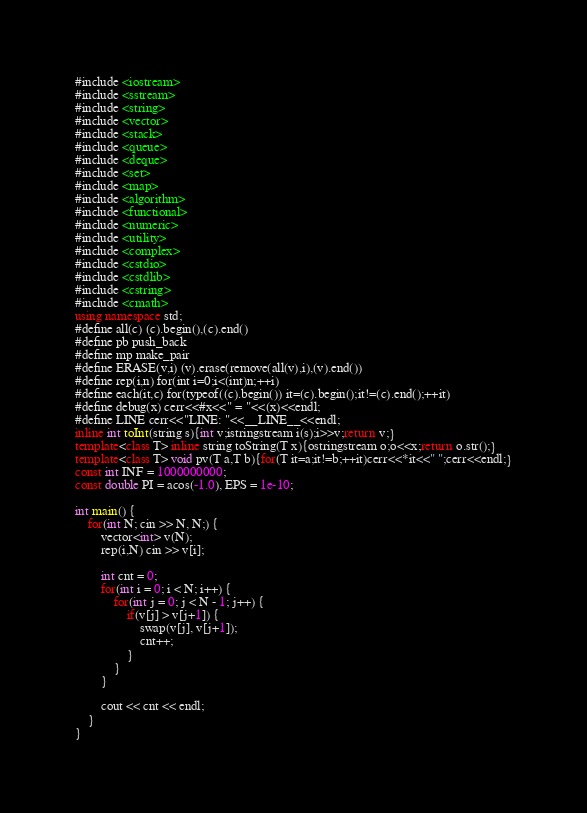Convert code to text. <code><loc_0><loc_0><loc_500><loc_500><_C++_>#include <iostream>
#include <sstream>
#include <string>
#include <vector>
#include <stack>
#include <queue>
#include <deque>
#include <set>
#include <map>
#include <algorithm>
#include <functional>
#include <numeric>
#include <utility>
#include <complex>
#include <cstdio>
#include <cstdlib>
#include <cstring>
#include <cmath>
using namespace std;
#define all(c) (c).begin(),(c).end()
#define pb push_back
#define mp make_pair
#define ERASE(v,i) (v).erase(remove(all(v),i),(v).end())
#define rep(i,n) for(int i=0;i<(int)n;++i)
#define each(it,c) for(typeof((c).begin()) it=(c).begin();it!=(c).end();++it)
#define debug(x) cerr<<#x<<" = "<<(x)<<endl;
#define LINE cerr<<"LINE: "<<__LINE__<<endl;
inline int toInt(string s){int v;istringstream i(s);i>>v;return v;}
template<class T> inline string toString(T x){ostringstream o;o<<x;return o.str();}
template<class T> void pv(T a,T b){for(T it=a;it!=b;++it)cerr<<*it<<" ";cerr<<endl;}
const int INF = 1000000000;
const double PI = acos(-1.0), EPS = 1e-10;

int main() {
	for(int N; cin >> N, N;) {
		vector<int> v(N);
		rep(i,N) cin >> v[i];
		
		int cnt = 0;
		for(int i = 0; i < N; i++) {
			for(int j = 0; j < N - 1; j++) {
				if(v[j] > v[j+1]) {
					swap(v[j], v[j+1]);
					cnt++;
				}
			}
		}
		
		cout << cnt << endl;
	}
}</code> 